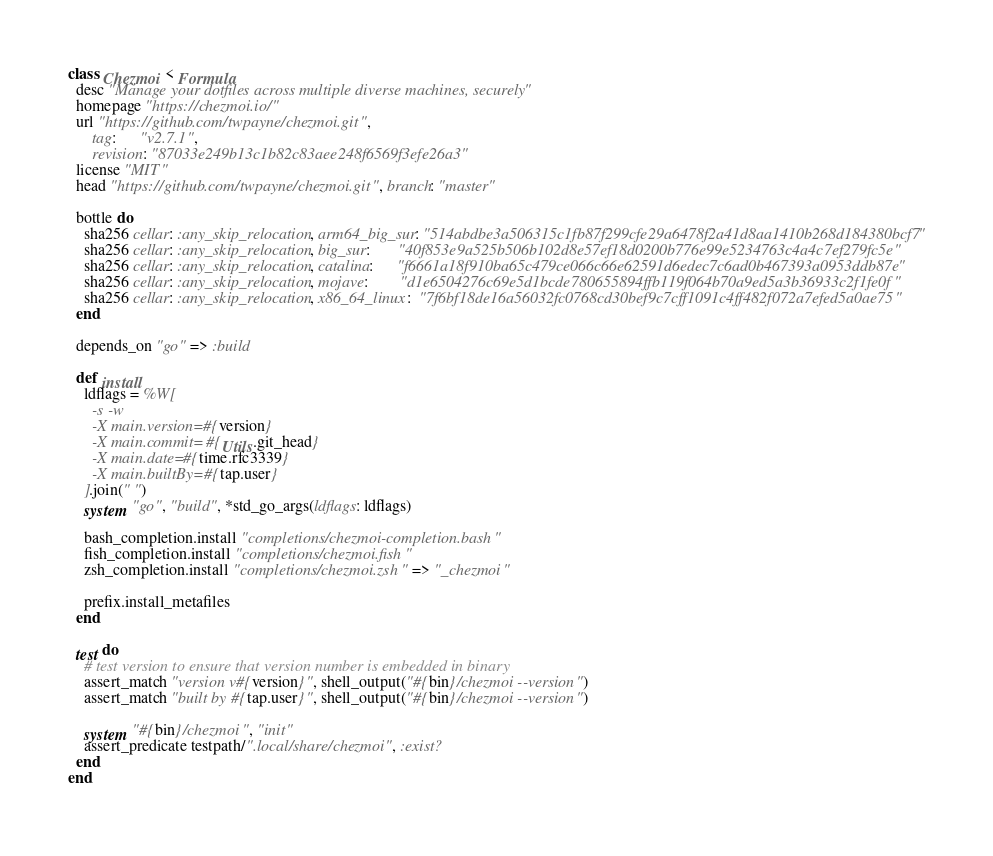<code> <loc_0><loc_0><loc_500><loc_500><_Ruby_>class Chezmoi < Formula
  desc "Manage your dotfiles across multiple diverse machines, securely"
  homepage "https://chezmoi.io/"
  url "https://github.com/twpayne/chezmoi.git",
      tag:      "v2.7.1",
      revision: "87033e249b13c1b82c83aee248f6569f3efe26a3"
  license "MIT"
  head "https://github.com/twpayne/chezmoi.git", branch: "master"

  bottle do
    sha256 cellar: :any_skip_relocation, arm64_big_sur: "514abdbe3a506315c1fb87f299cfe29a6478f2a41d8aa1410b268d184380bcf7"
    sha256 cellar: :any_skip_relocation, big_sur:       "40f853e9a525b506b102d8e57ef18d0200b776e99e5234763c4a4c7ef279fc5e"
    sha256 cellar: :any_skip_relocation, catalina:      "f6661a18f910ba65c479ce066c66e62591d6edec7c6ad0b467393a0953ddb87e"
    sha256 cellar: :any_skip_relocation, mojave:        "d1e6504276c69e5d1bcde780655894ffb119f064b70a9ed5a3b36933c2f1fe0f"
    sha256 cellar: :any_skip_relocation, x86_64_linux:  "7f6bf18de16a56032fc0768cd30bef9c7cff1091c4ff482f072a7efed5a0ae75"
  end

  depends_on "go" => :build

  def install
    ldflags = %W[
      -s -w
      -X main.version=#{version}
      -X main.commit=#{Utils.git_head}
      -X main.date=#{time.rfc3339}
      -X main.builtBy=#{tap.user}
    ].join(" ")
    system "go", "build", *std_go_args(ldflags: ldflags)

    bash_completion.install "completions/chezmoi-completion.bash"
    fish_completion.install "completions/chezmoi.fish"
    zsh_completion.install "completions/chezmoi.zsh" => "_chezmoi"

    prefix.install_metafiles
  end

  test do
    # test version to ensure that version number is embedded in binary
    assert_match "version v#{version}", shell_output("#{bin}/chezmoi --version")
    assert_match "built by #{tap.user}", shell_output("#{bin}/chezmoi --version")

    system "#{bin}/chezmoi", "init"
    assert_predicate testpath/".local/share/chezmoi", :exist?
  end
end
</code> 